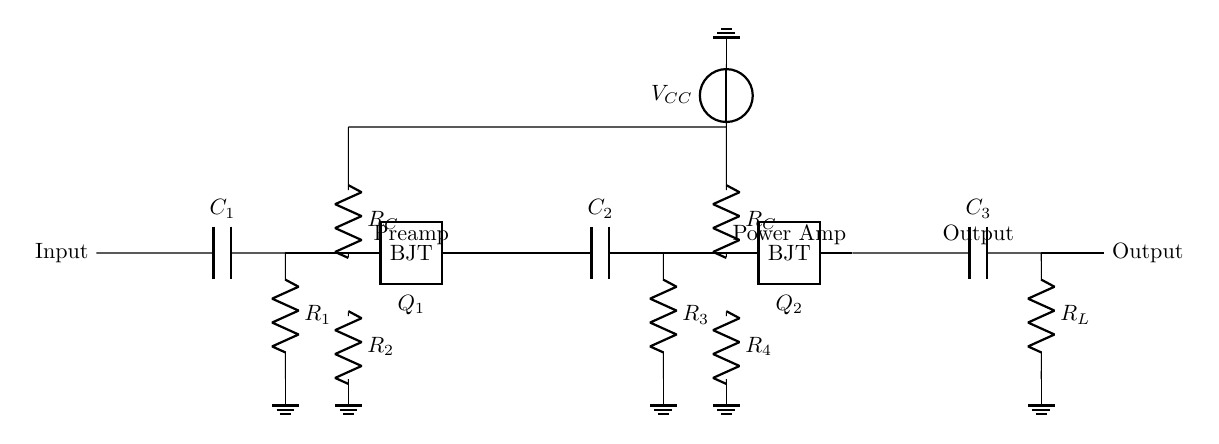What components are used in the input stage? The input stage contains a capacitor and two resistors, specifically C1 and R1, as well as a BJT labeled Q1.
Answer: C1, R1, Q1 What is the role of capacitor C2 in the circuit? Capacitor C2 is used for coupling between stages, allowing AC signals to pass while blocking DC components, thus ensuring the signal from the first BJT (Q1) reaches the second stage without DC offset.
Answer: Coupling How many BJTs are present in the amplifier circuit? There are two BJTs (Q1 and Q2) used in the circuit for amplification in the preamp and power amp stages respectively.
Answer: Two What does R_L represent in this circuit? R_L is the load resistor connected at the output stage, which is essential for converting the amplified signal to a usable output.
Answer: Load resistor What type of amplifier stages are present in this circuit? The circuit comprises a preamplifier stage and a power amplifier stage, which work together to increase the audio signals' levels before outputting.
Answer: Preamplifier and power amplifier What is the significance of the V_CC power supply in this circuit? V_CC provides the necessary voltage supply for the BJTs to operate, crucial for their functionality and ensuring the circuit can amplify audio signals effectively.
Answer: Power supply voltage 